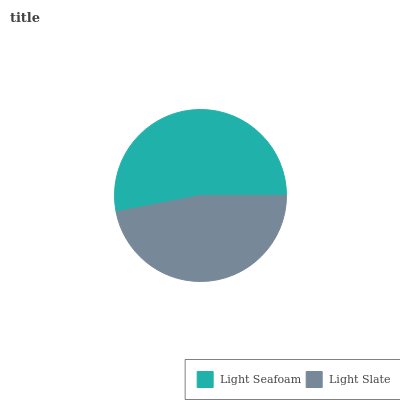Is Light Slate the minimum?
Answer yes or no. Yes. Is Light Seafoam the maximum?
Answer yes or no. Yes. Is Light Slate the maximum?
Answer yes or no. No. Is Light Seafoam greater than Light Slate?
Answer yes or no. Yes. Is Light Slate less than Light Seafoam?
Answer yes or no. Yes. Is Light Slate greater than Light Seafoam?
Answer yes or no. No. Is Light Seafoam less than Light Slate?
Answer yes or no. No. Is Light Seafoam the high median?
Answer yes or no. Yes. Is Light Slate the low median?
Answer yes or no. Yes. Is Light Slate the high median?
Answer yes or no. No. Is Light Seafoam the low median?
Answer yes or no. No. 